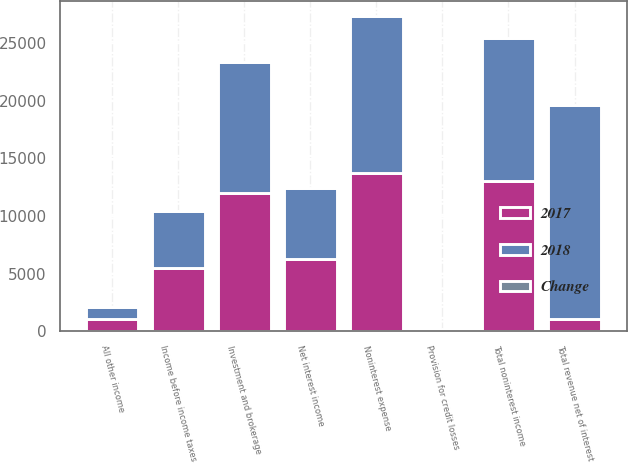Convert chart. <chart><loc_0><loc_0><loc_500><loc_500><stacked_bar_chart><ecel><fcel>Net interest income<fcel>Investment and brokerage<fcel>All other income<fcel>Total noninterest income<fcel>Total revenue net of interest<fcel>Provision for credit losses<fcel>Noninterest expense<fcel>Income before income taxes<nl><fcel>2017<fcel>6294<fcel>11959<fcel>1085<fcel>13044<fcel>1085<fcel>86<fcel>13777<fcel>5475<nl><fcel>2018<fcel>6173<fcel>11394<fcel>1023<fcel>12417<fcel>18590<fcel>56<fcel>13556<fcel>4978<nl><fcel>Change<fcel>2<fcel>5<fcel>6<fcel>5<fcel>4<fcel>54<fcel>2<fcel>10<nl></chart> 